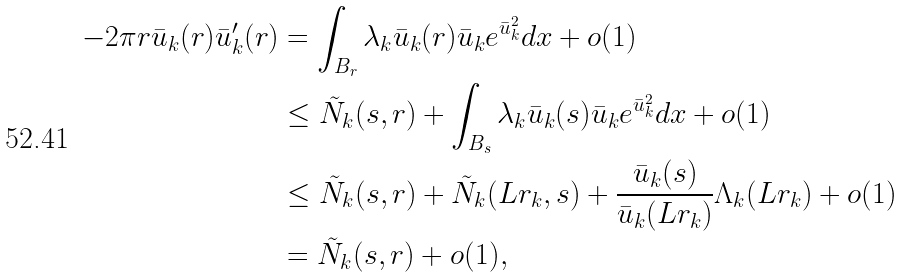Convert formula to latex. <formula><loc_0><loc_0><loc_500><loc_500>- 2 \pi r \bar { u } _ { k } ( r ) \bar { u } _ { k } ^ { \prime } ( r ) & = \int _ { B _ { r } } \lambda _ { k } \bar { u } _ { k } ( r ) \bar { u } _ { k } e ^ { \bar { u } _ { k } ^ { 2 } } d x + o ( 1 ) \\ & \leq \tilde { N } _ { k } ( s , r ) + \int _ { B _ { s } } \lambda _ { k } \bar { u } _ { k } ( s ) \bar { u } _ { k } e ^ { \bar { u } _ { k } ^ { 2 } } d x + o ( 1 ) \\ & \leq \tilde { N } _ { k } ( s , r ) + \tilde { N } _ { k } ( L r _ { k } , s ) + \frac { \bar { u } _ { k } ( s ) } { \bar { u } _ { k } ( L r _ { k } ) } \Lambda _ { k } ( L r _ { k } ) + o ( 1 ) \\ & = \tilde { N } _ { k } ( s , r ) + o ( 1 ) ,</formula> 